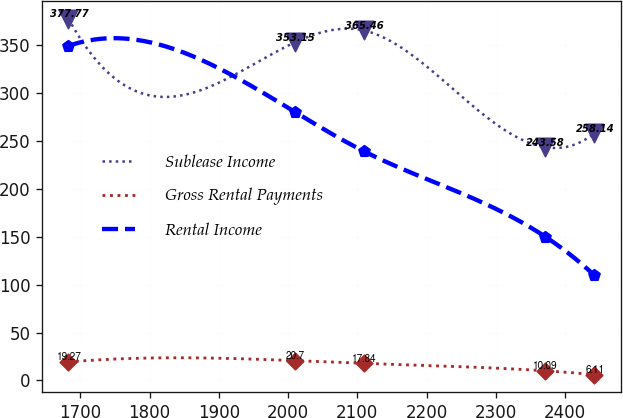Convert chart to OTSL. <chart><loc_0><loc_0><loc_500><loc_500><line_chart><ecel><fcel>Sublease Income<fcel>Gross Rental Payments<fcel>Rental Income<nl><fcel>1682.84<fcel>377.77<fcel>19.27<fcel>349.37<nl><fcel>2010.29<fcel>353.15<fcel>20.7<fcel>280.25<nl><fcel>2109.73<fcel>365.46<fcel>17.84<fcel>239.27<nl><fcel>2371.36<fcel>243.58<fcel>10.09<fcel>150.2<nl><fcel>2442.44<fcel>258.14<fcel>6.11<fcel>109.83<nl></chart> 